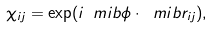Convert formula to latex. <formula><loc_0><loc_0><loc_500><loc_500>\chi _ { i j } = \exp ( i \ m i b { \phi } \cdot \ m i b { r } _ { i j } ) ,</formula> 